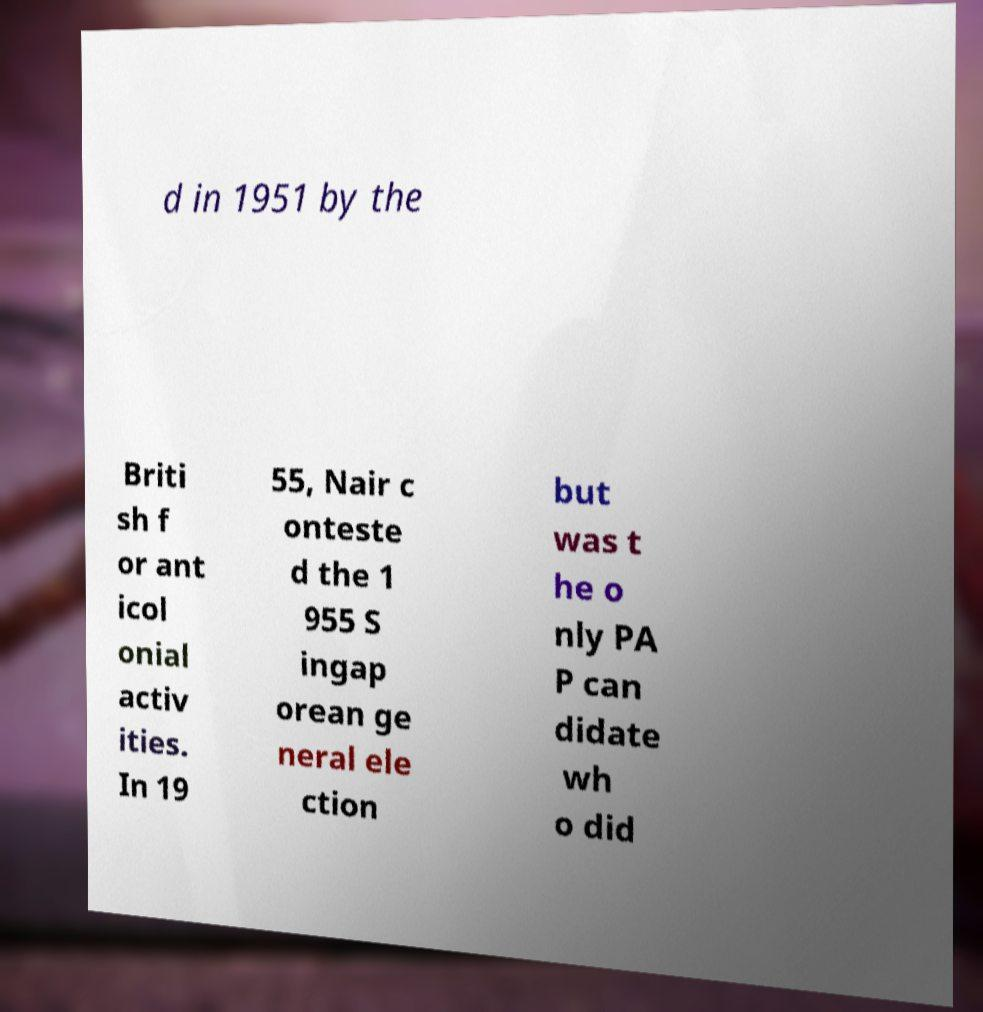Can you accurately transcribe the text from the provided image for me? d in 1951 by the Briti sh f or ant icol onial activ ities. In 19 55, Nair c onteste d the 1 955 S ingap orean ge neral ele ction but was t he o nly PA P can didate wh o did 